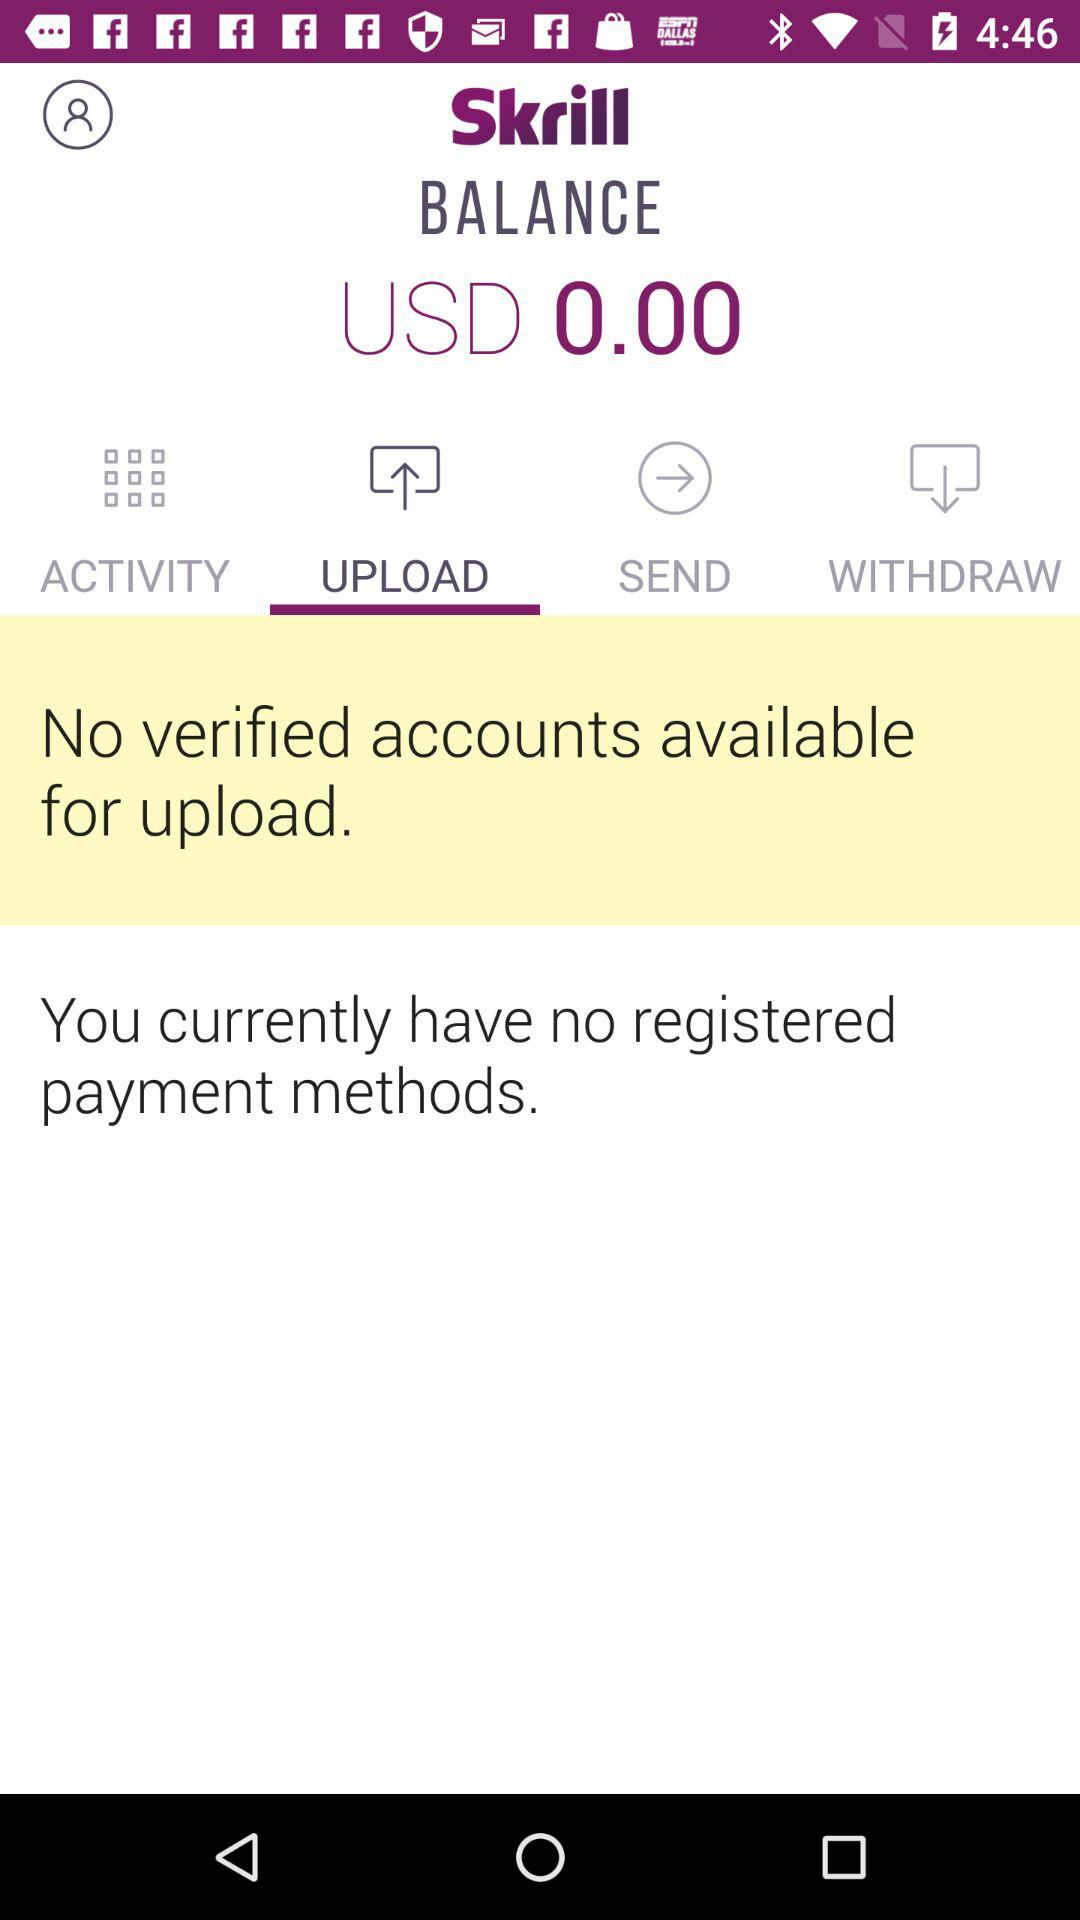How much USD is shown on the screen? The USD shown on the screen is 0.00. 